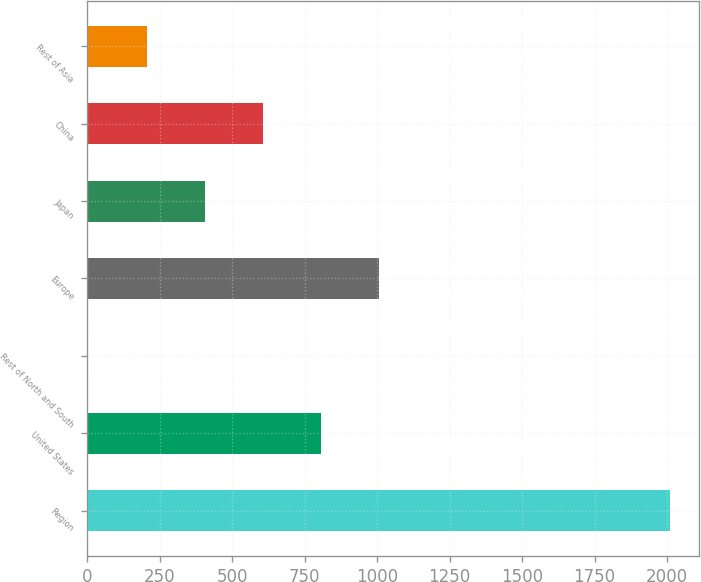Convert chart. <chart><loc_0><loc_0><loc_500><loc_500><bar_chart><fcel>Region<fcel>United States<fcel>Rest of North and South<fcel>Europe<fcel>Japan<fcel>China<fcel>Rest of Asia<nl><fcel>2009<fcel>806.6<fcel>5<fcel>1007<fcel>405.8<fcel>606.2<fcel>205.4<nl></chart> 